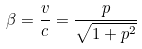<formula> <loc_0><loc_0><loc_500><loc_500>\beta = \frac { v } { c } = \frac { p } { \sqrt { 1 + p ^ { 2 } } }</formula> 